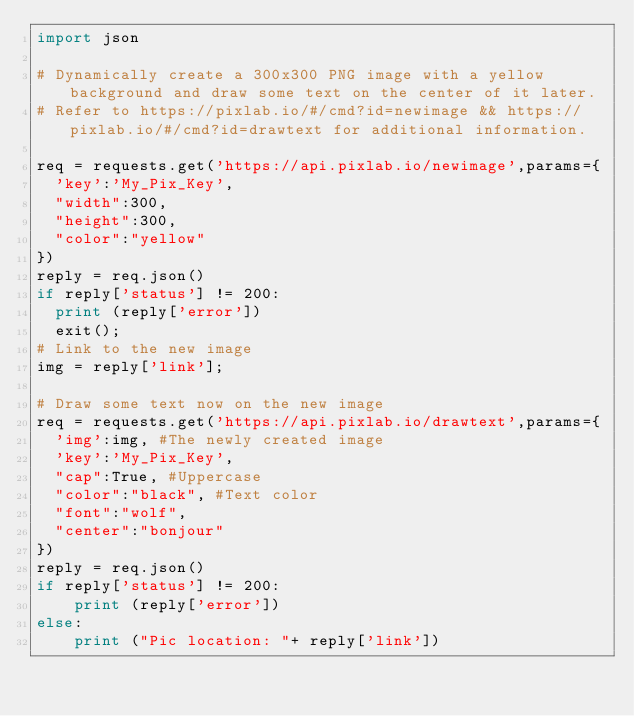Convert code to text. <code><loc_0><loc_0><loc_500><loc_500><_Python_>import json

# Dynamically create a 300x300 PNG image with a yellow background and draw some text on the center of it later.
# Refer to https://pixlab.io/#/cmd?id=newimage && https://pixlab.io/#/cmd?id=drawtext for additional information.

req = requests.get('https://api.pixlab.io/newimage',params={
	'key':'My_Pix_Key',
	"width":300,
	"height":300,
	"color":"yellow"
})
reply = req.json()
if reply['status'] != 200:
	print (reply['error'])
	exit();
# Link to the new image
img = reply['link'];

# Draw some text now on the new image
req = requests.get('https://api.pixlab.io/drawtext',params={
	'img':img, #The newly created image
	'key':'My_Pix_Key',
	"cap":True, #Uppercase
	"color":"black", #Text color
	"font":"wolf",
	"center":"bonjour"
})
reply = req.json()
if reply['status'] != 200:
    print (reply['error'])
else:
    print ("Pic location: "+ reply['link'])
</code> 